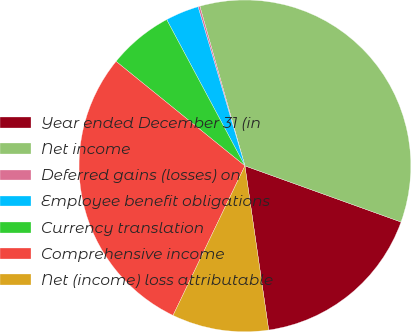<chart> <loc_0><loc_0><loc_500><loc_500><pie_chart><fcel>Year ended December 31 (in<fcel>Net income<fcel>Deferred gains (losses) on<fcel>Employee benefit obligations<fcel>Currency translation<fcel>Comprehensive income<fcel>Net (income) loss attributable<nl><fcel>17.22%<fcel>34.88%<fcel>0.18%<fcel>3.26%<fcel>6.34%<fcel>28.72%<fcel>9.42%<nl></chart> 